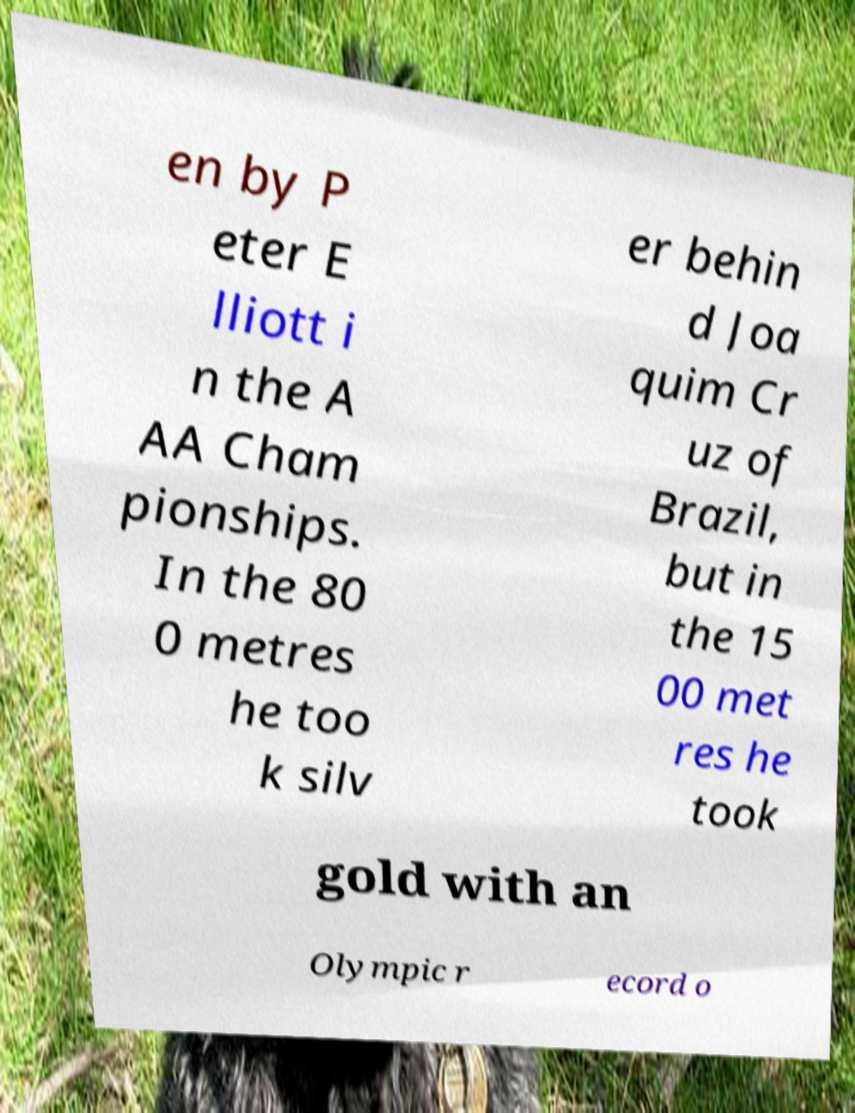There's text embedded in this image that I need extracted. Can you transcribe it verbatim? en by P eter E lliott i n the A AA Cham pionships. In the 80 0 metres he too k silv er behin d Joa quim Cr uz of Brazil, but in the 15 00 met res he took gold with an Olympic r ecord o 